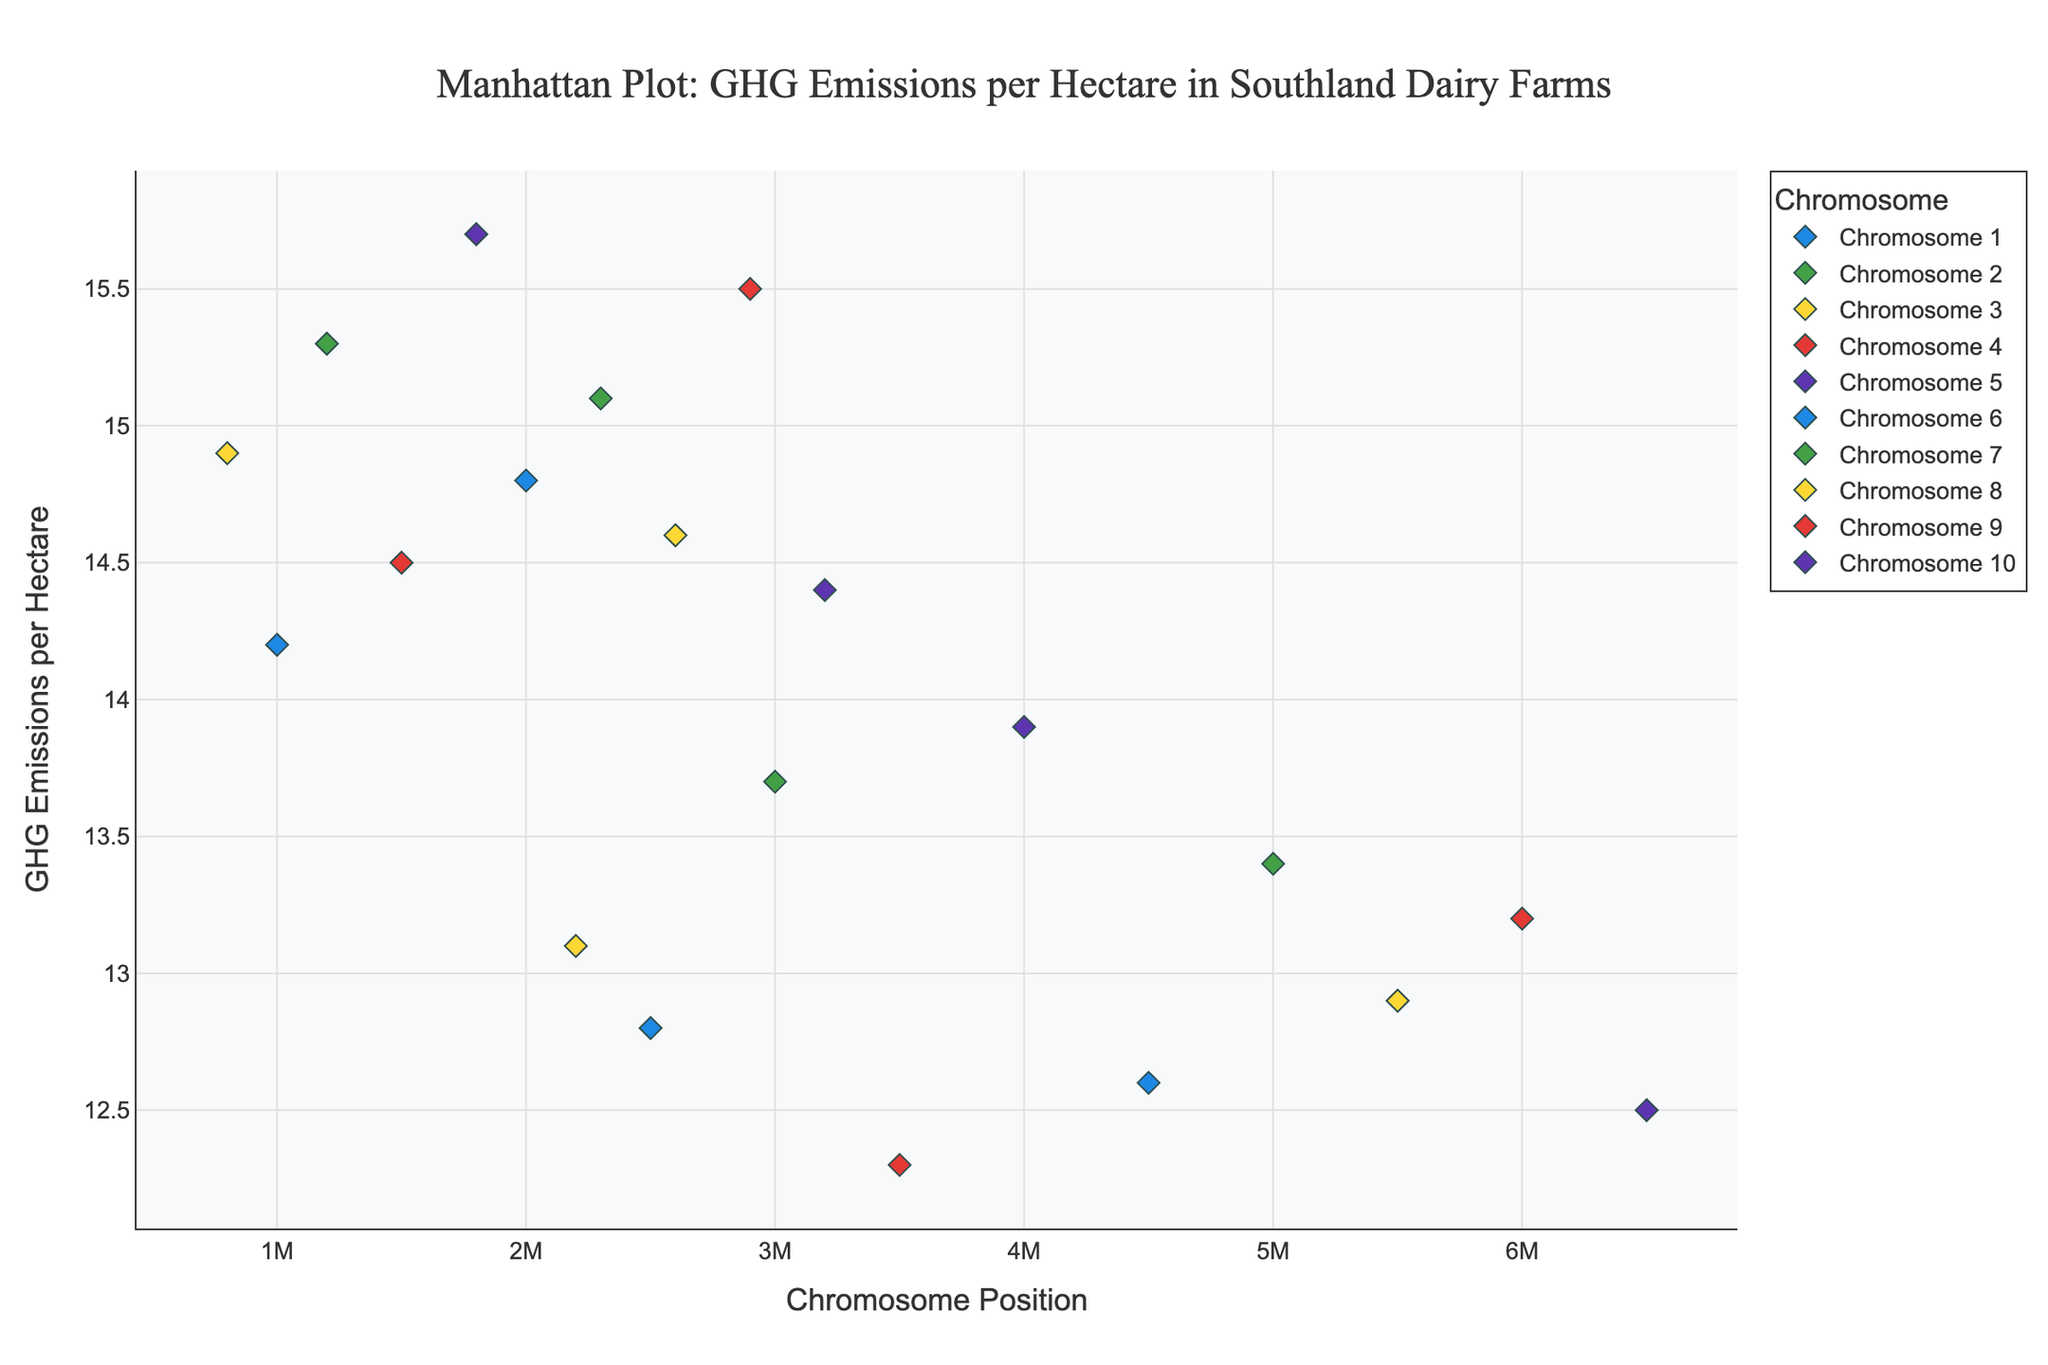What is the title of the plot? The title is usually found at the top center of the plot for easy identification.
Answer: Manhattan Plot: GHG Emissions per Hectare in Southland Dairy Farms Which farm has the highest GHG emissions per hectare? Look for the highest point on the y-axis and identify the farm from the hover information.
Answer: Tuatapere Valleys Which chromosome has the most data points? Count the number of markers for each chromosome. Chromosome with the most markers has the most data points.
Answer: Chromosome 7 What is the GHG emission per hectare for Heddon Bush Farms? Identify the marker for Heddon Bush Farms and read its y-axis value.
Answer: 12.8 What range of GHG emissions per hectare does the plot cover? Find the minimum and maximum y-values on the plot to determine the range.
Answer: 12.3 to 15.7 Which farm on chromosome 9 has lower GHG emissions, Mossburn Meadows or Tokanui Farm? Compare the y-axis values for the markers on chromosome 9 labeled with these farms.
Answer: Mossburn Meadows What is the average GHG emissions per hectare for farms on chromosome 3? Add the GHG emissions for all farms on chromosome 3 and divide by the number of farms. (14.9 + 13.1) / 2 = 14
Answer: 14 How many chromosomes are represented in the plot? Count the distinct chromosome labels on the x-axis.
Answer: 10 Between Nightcaps Grassland and Riverton Grasslands, which farm has a higher GHG emission per hectare? Compare the y-axis values for the markers labeled Nightcaps Grassland and Riverton Grasslands.
Answer: Nightcaps Grassland What is the visual color used for the data points on chromosome 1? Identify the color used for markers corresponding to chromosome 1 by observing the legend.
Answer: Blue 